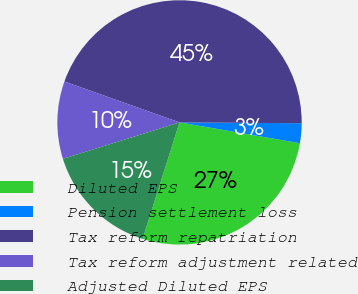<chart> <loc_0><loc_0><loc_500><loc_500><pie_chart><fcel>Diluted EPS<fcel>Pension settlement loss<fcel>Tax reform repatriation<fcel>Tax reform adjustment related<fcel>Adjusted Diluted EPS<nl><fcel>27.16%<fcel>2.62%<fcel>44.67%<fcel>10.26%<fcel>15.29%<nl></chart> 